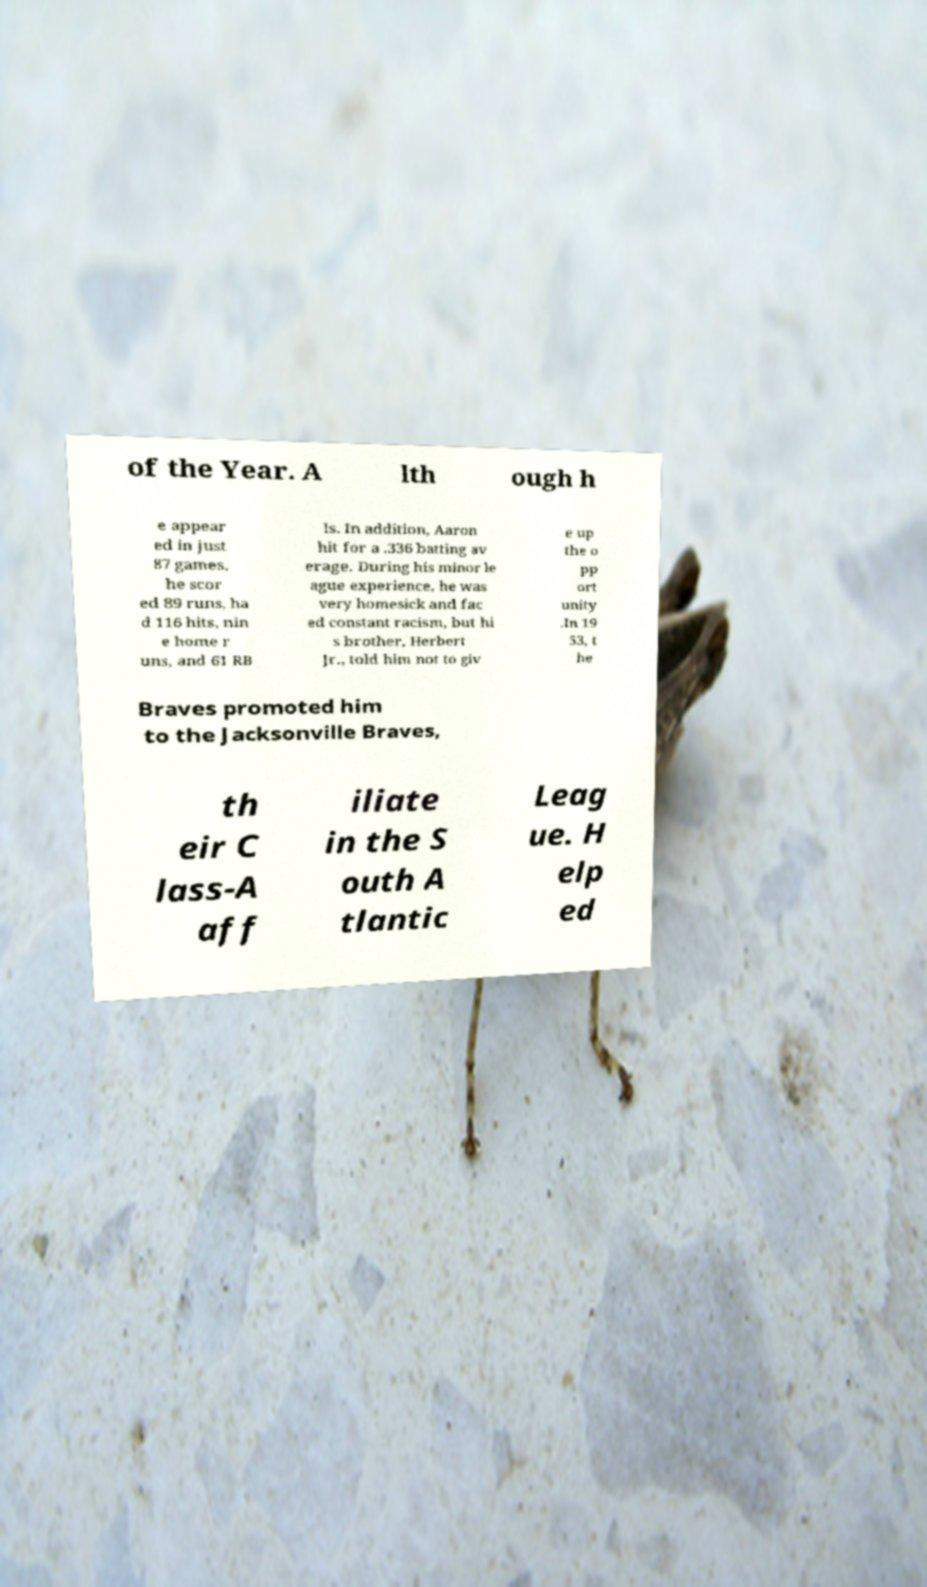Could you extract and type out the text from this image? of the Year. A lth ough h e appear ed in just 87 games, he scor ed 89 runs, ha d 116 hits, nin e home r uns, and 61 RB Is. In addition, Aaron hit for a .336 batting av erage. During his minor le ague experience, he was very homesick and fac ed constant racism, but hi s brother, Herbert Jr., told him not to giv e up the o pp ort unity .In 19 53, t he Braves promoted him to the Jacksonville Braves, th eir C lass-A aff iliate in the S outh A tlantic Leag ue. H elp ed 